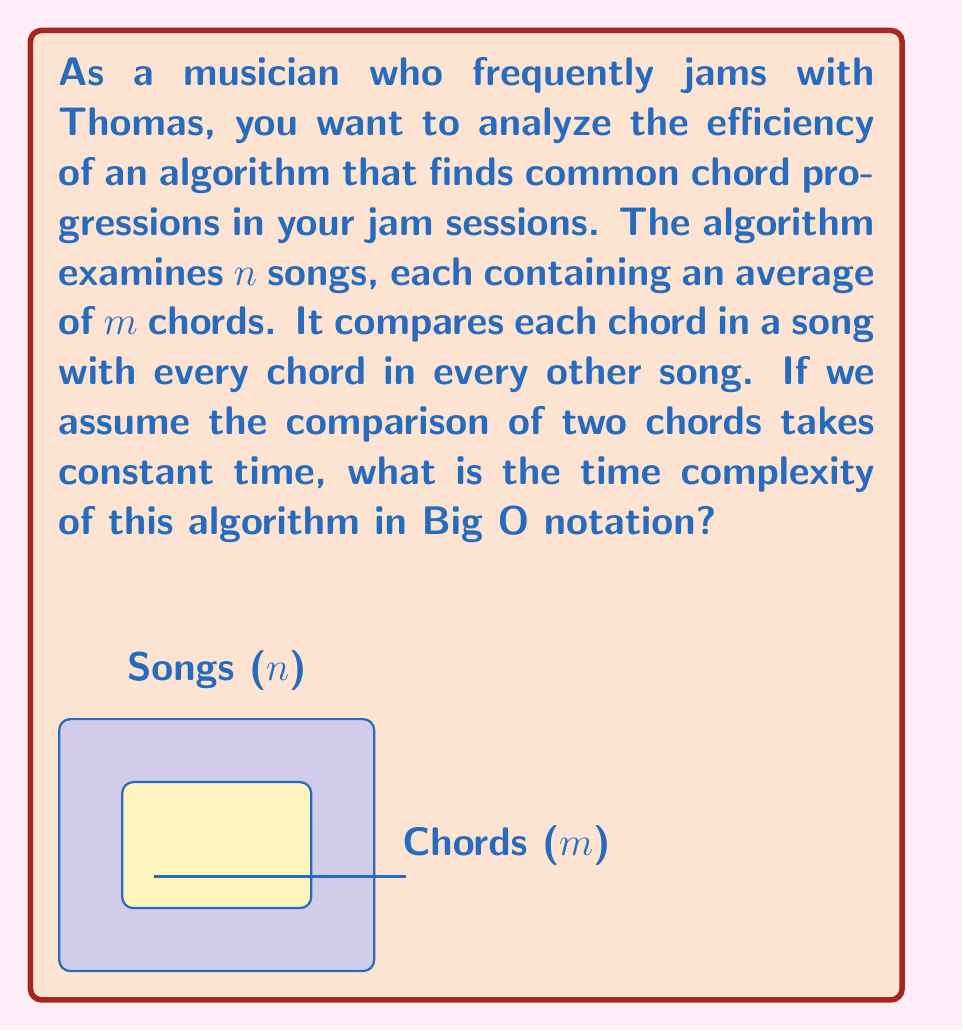Could you help me with this problem? Let's break down the problem step-by-step:

1) We have $n$ songs, each with an average of $m$ chords.

2) For each song, the algorithm needs to compare its chords with the chords of all other songs.

3) The number of comparisons for one song:
   - It compares with $(n-1)$ other songs
   - For each of these comparisons, it compares all $m$ chords
   - So, one song makes $m \cdot (n-1)$ comparisons

4) This process is repeated for all $n$ songs.

5) However, we need to account for the fact that each pair of songs is compared twice (Song A to Song B, and Song B to Song A).

6) Therefore, the total number of comparisons is:

   $$\frac{n \cdot m \cdot (n-1)}{2}$$

7) Expanding this expression:

   $$\frac{n^2m - nm}{2}$$

8) In Big O notation, we ignore constants and lower-order terms. The dominant term here is $n^2m$.

Therefore, the time complexity of this algorithm is $O(n^2m)$.
Answer: $O(n^2m)$ 